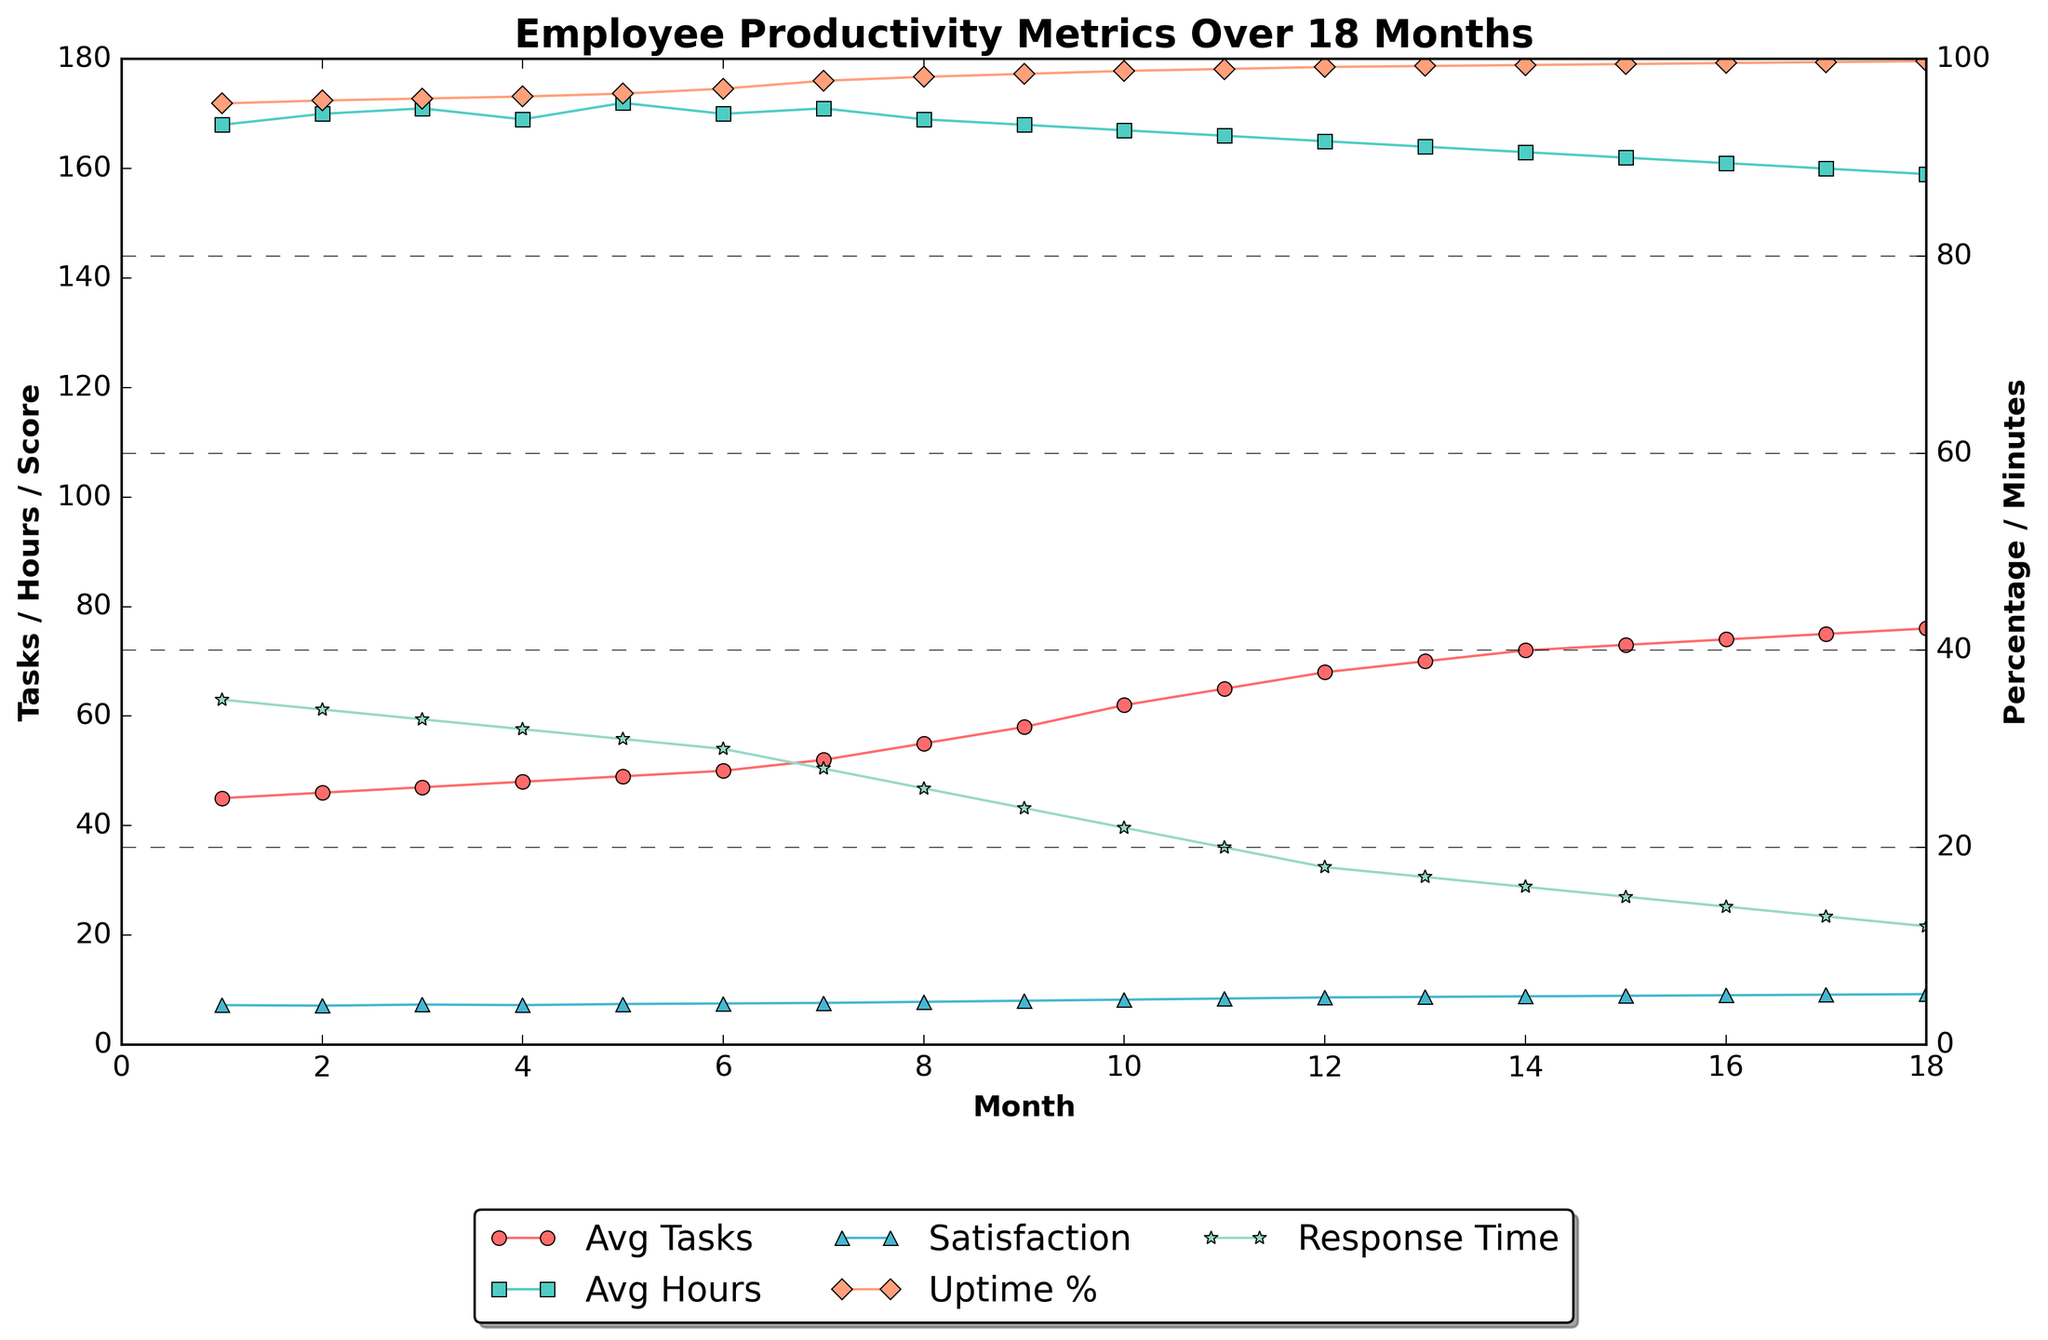How does the Average Tasks Completed change over the 18 months? To see how the Average Tasks Completed changes, observe the red line with circular markers on the chart. The values progressively increase from 45 in the first month to 76 in the eighteenth month.
Answer: It increases During which month is the Customer Response Time the lowest? To find the lowest Customer Response Time, look at the green line with star markers. The lowest response time is at Month 18, where the time is 12 minutes.
Answer: Month 18 Compare the Employee Satisfaction Score at Month 1 and Month 18. By how much has it increased? The blue line with triangular markers represents the Employee Satisfaction Score. At Month 1, the score is 7.2, and at Month 18, it is 9.2. The increase is 9.2 - 7.2 = 2.0.
Answer: 2.0 What is the difference in System Uptime Percentage between Month 6 and Month 12? The orange line with diamond markers represents System Uptime Percentage. At Month 6, the percentage is 97.0%, and at Month 12, it is 99.2%. The difference is 99.2% - 97.0% = 2.2%.
Answer: 2.2% Which metric saw the largest relative percentage improvement over the 18 months? To determine the largest relative percentage improvement, calculate the relative increase for each metric, \( (Final - Initial) / Initial \times 100 \), for each series. The largest relative percentage improvement is found for System Uptime Percentage, increasing from 95.5% to 99.8%, approximately \( (99.8 - 95.5) / 95.5 \times 100 \approx 4.5\% \).
Answer: System Uptime Percentage During which month is the increase in Average Tasks Completed the most significant compared to the previous month? To identify the most significant increase in Average Tasks Completed, look for the steepest upward slope in the red line. The most significant increase is between Month 8 and Month 9, from 55 to 58 tasks, which is an increment of 3 tasks.
Answer: Month 9 From the chart, how does Average Hours Worked correlate with Employee Satisfaction Score? To determine correlation, observe the trend and slope of the turquoise line (Average Hours Worked) and the blue line (Employee Satisfaction Score). As the Average Hours Worked decreases from 168 to 159, the Employee Satisfaction Score increases from 7.2 to 9.2, showing a negative correlation.
Answer: Negative correlation In which month does the Average Hours Worked drop below 170? Looking at the turquoise line with square markers, identify when the line first drops below the 170 mark. This occurs in Month 6 when the average is 170, and it decreases subsequently.
Answer: Month 7 What is the average Customer Response Time for Months 1 through 6? To find this, calculate the arithmetic mean of values for Months 1 to 6 (35, 34, 33, 32, 31, 30). Sum these values: 35 + 34 + 33 + 32 + 31 + 30 = 195. There are 6 data points, so the average is 195 / 6 = 32.5.
Answer: 32.5 